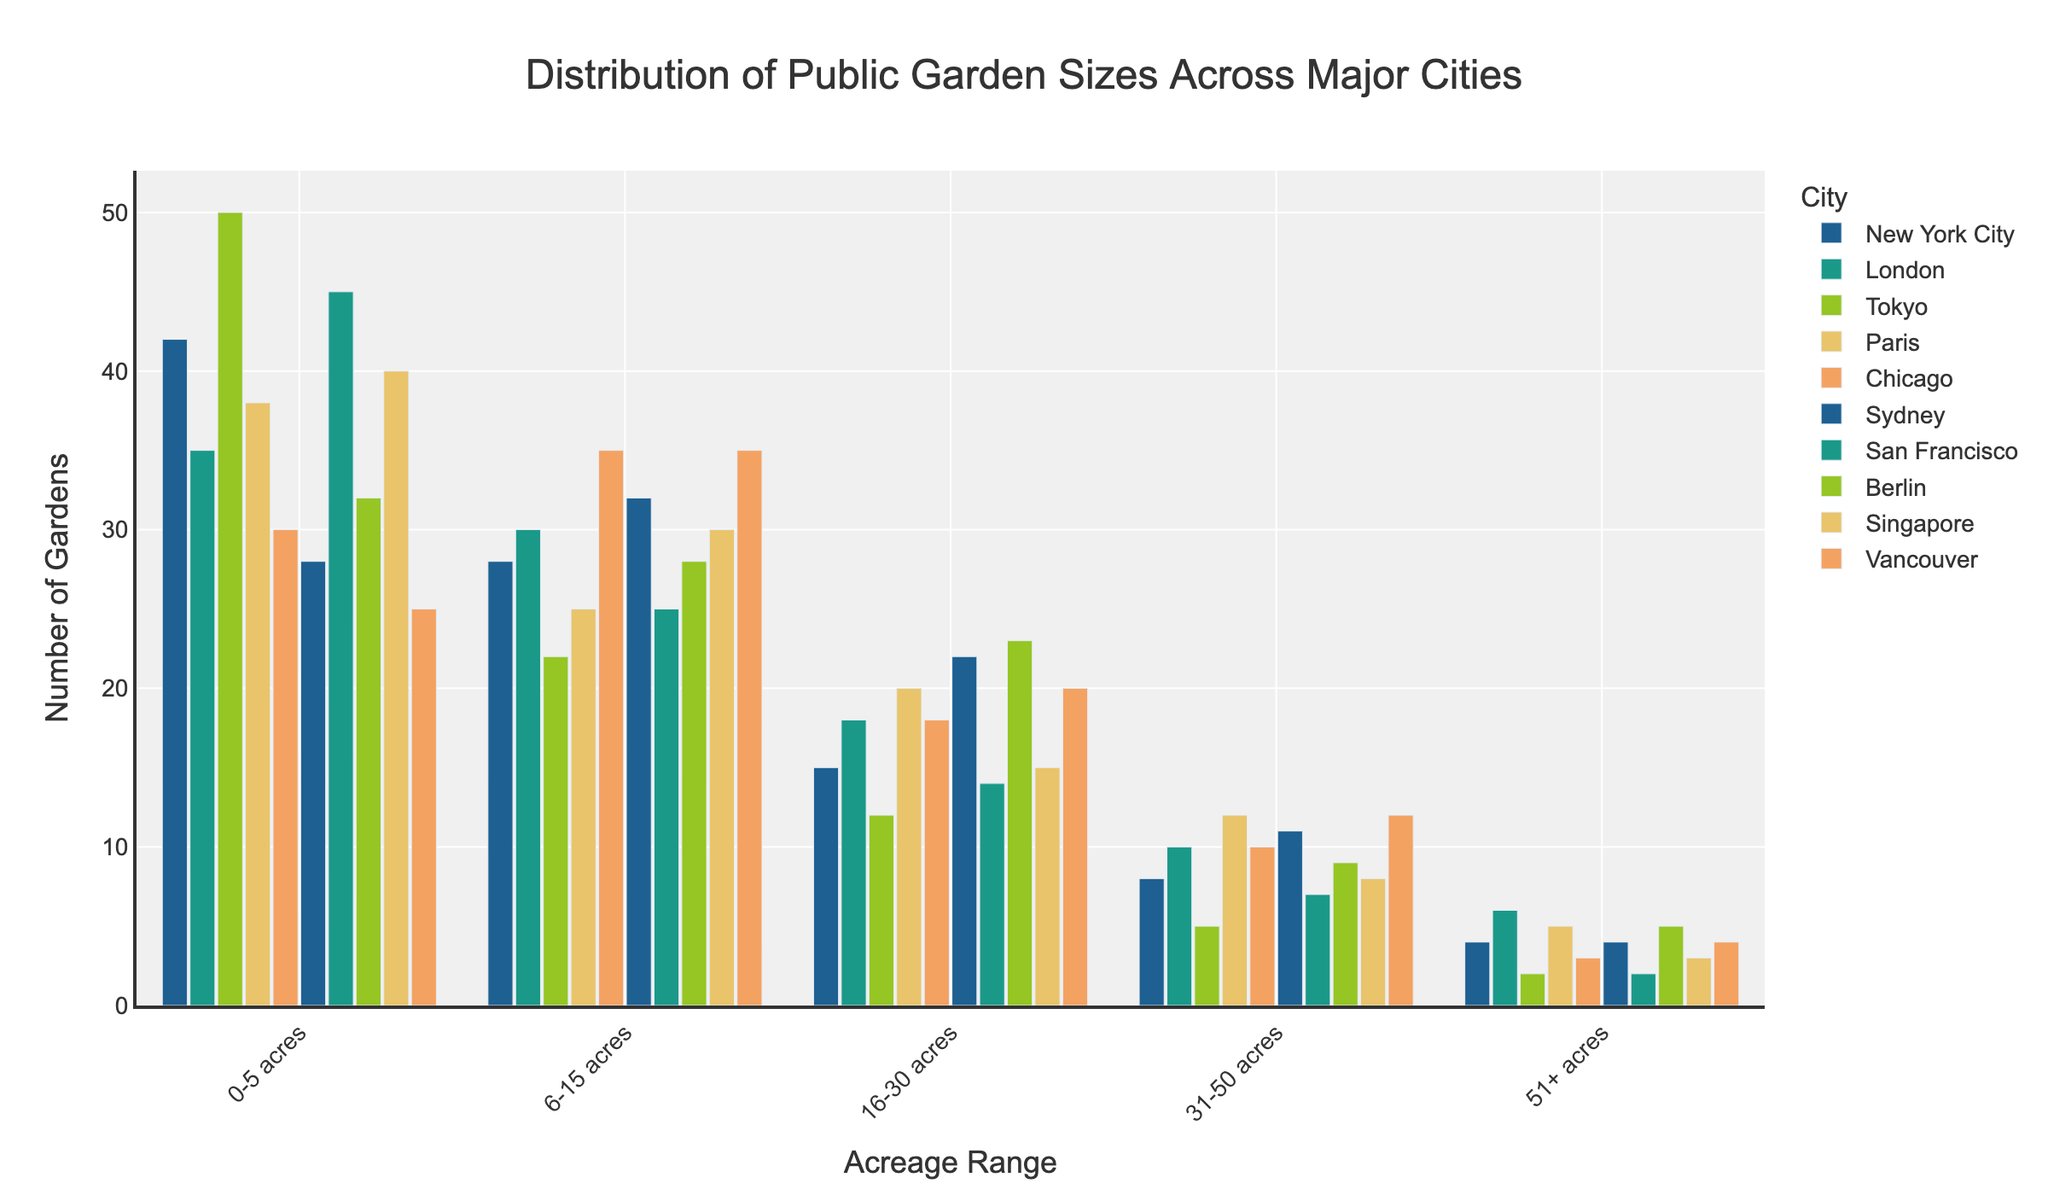Which city has the most public gardens with the smallest acreage (0-5 acres)? By looking at the bar heights in the 0-5 acres category, the city with the tallest bar represents the highest number of public gardens in that acreage range. Tokyo has the tallest bar in this category.
Answer: Tokyo How many public gardens in total are there in Paris with an acreage greater than 15 acres? Sum the number of public gardens in the categories 16-30 acres, 31-50 acres, and 51+ acres for Paris. They are 20, 12, and 5 respectively. Hence, the total is 20 + 12 + 5 = 37.
Answer: 37 Which city has the fewest public gardens in the 31-50 acres category? Compare the bar heights for the 31-50 acres category across all cities. The shortest bar for this category is located in Tokyo.
Answer: Tokyo In which acreage category does San Francisco have the highest number of gardens compared to other categories within the same city? By examining San Francisco's bar heights, the tallest bar represents the category with the highest number of gardens. For San Francisco, the 0-5 acres category has the tallest bar.
Answer: 0-5 acres Which two cities have the same number of public gardens in the 6-15 acres category? Identify the bars with equal heights in the 6-15 acres category. New York City and Singapore both have a bar height of 30 in this category.
Answer: New York City and Singapore What is the difference in the number of public gardens with an acreage of 0-5 acres between Berlin and Sydney? Compare the bar heights for the 0-5 acres category in Berlin and Sydney. Berlin has 32 gardens and Sydney has 28 gardens in this category. The difference is 32 - 28 = 4.
Answer: 4 For Chicago, what is the ratio of public gardens in the 16-30 acres category to those in the 51+ acres category? For Chicago, there are 18 gardens in the 16-30 acres category and 3 gardens in the 51+ acres category. The ratio is 18 / 3 = 6.
Answer: 6 Which city has the second-highest number of public gardens in the 51+ acres category? Rank the numbers in the 51+ acres category and identify the city with the second tallest bar. London has the second-highest number with 6 gardens.
Answer: London What is the sum of public gardens in the 0-5 acres and 6-15 acres categories in Vancouver? Add the number of gardens in the 0-5 acres and 6-15 acres categories for Vancouver. They are 25 and 35 respectively. The sum is 25 + 35 = 60.
Answer: 60 